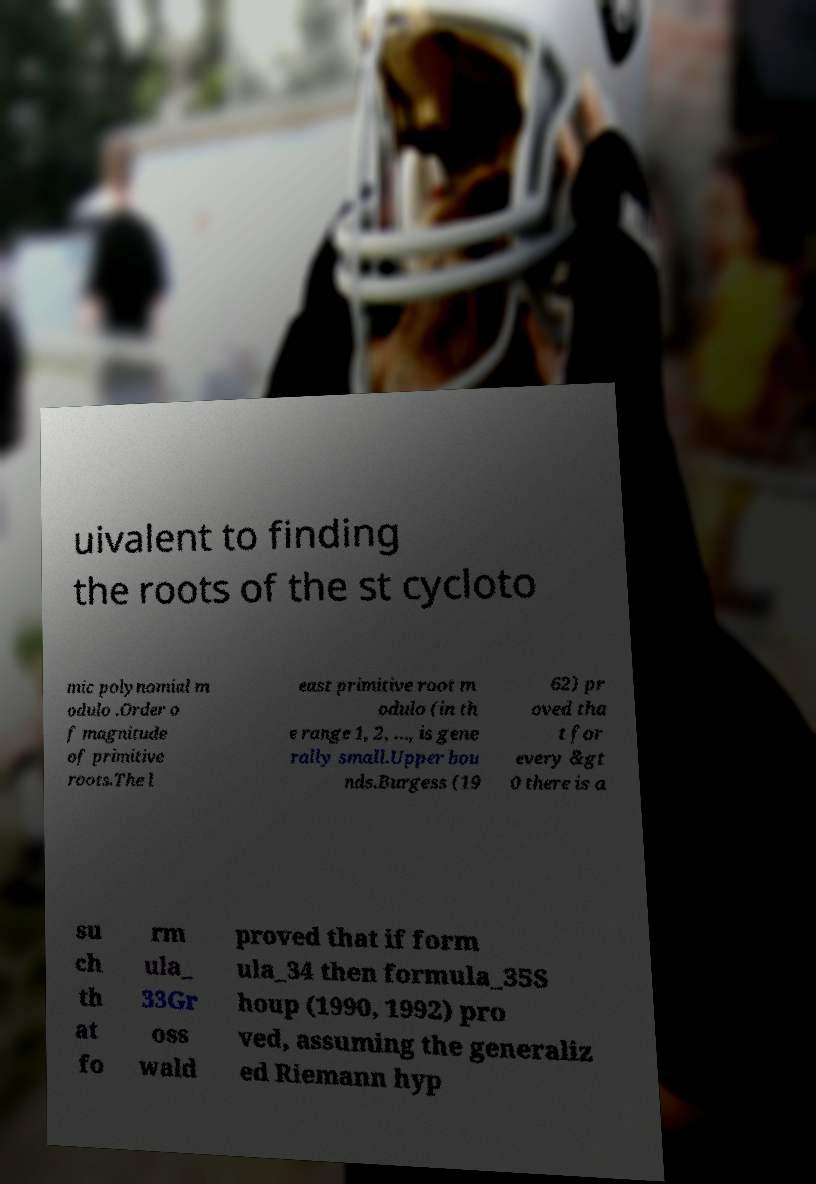Please read and relay the text visible in this image. What does it say? uivalent to finding the roots of the st cycloto mic polynomial m odulo .Order o f magnitude of primitive roots.The l east primitive root m odulo (in th e range 1, 2, ..., is gene rally small.Upper bou nds.Burgess (19 62) pr oved tha t for every &gt 0 there is a su ch th at fo rm ula_ 33Gr oss wald proved that if form ula_34 then formula_35S houp (1990, 1992) pro ved, assuming the generaliz ed Riemann hyp 